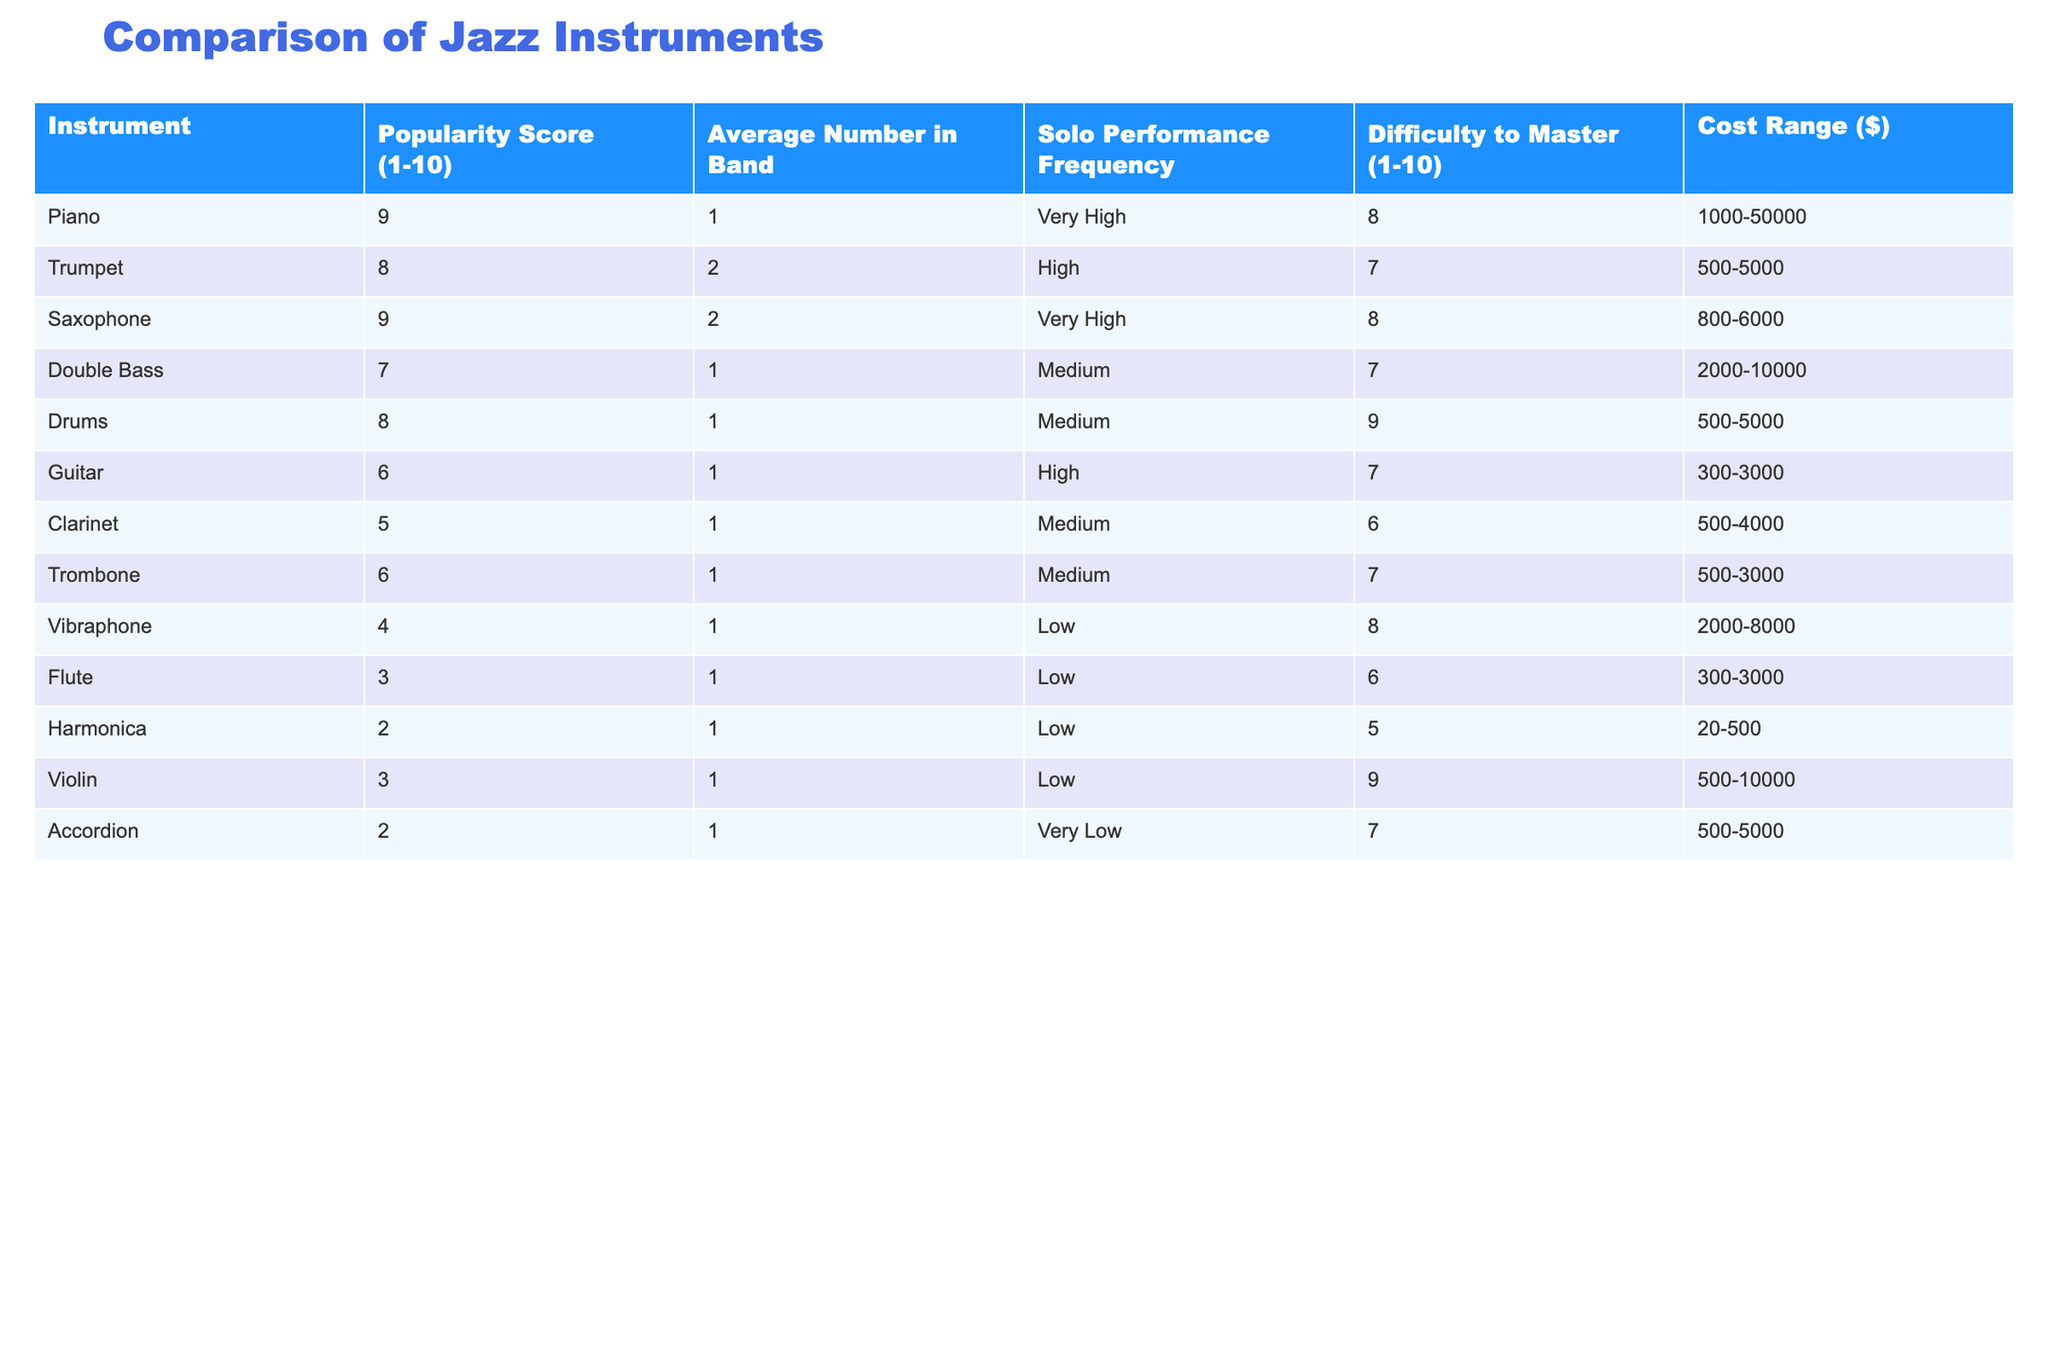What is the popularity score of the Saxophone? The Saxophone's popularity score is listed in the table under the "Popularity Score (1-10)" column, which specifically mentions the score as 9.
Answer: 9 Which instrument has the highest average number in a band? Referring to the "Average Number in Band" column, the Trumpet and Saxophone both have an average of 2, which is higher than any other instrument.
Answer: Trumpet and Saxophone What is the cost range for the Piano? The cost range for the Piano is listed in the "Cost Range ($)" column as 1000-50000.
Answer: 1000-50000 Is it true that the Clarinet is easier to master than the Harmonica? Comparing the "Difficulty to Master (1-10)" scores, the Clarinet has a score of 6 while the Harmonica has a score of 5. A lower score indicates that it is easier to master, thus making the statement true.
Answer: Yes What is the average popularity score of instruments with a solo performance frequency rated as low? The instruments with a low solo performance frequency are Flute, Harmonica, and Accordion. Their respective popularity scores are 3, 2, and 2. To find the average, sum these scores: 3 + 2 + 2 = 7, then divide by 3, yielding an average of 7/3 = approximately 2.33.
Answer: Approximately 2.33 Which instrument requires the highest level of difficulty to master, and what is that score? Reviewing the "Difficulty to Master (1-10)" column, the Drums have the highest score of 9, indicating it is the hardest to master.
Answer: Drums, 9 What is the most popular instrument based on the table? The instruments with the highest popularity scores are Piano and Saxophone, both receiving a score of 9. Thus, either can be considered the most popular.
Answer: Piano and Saxophone How many instruments have a popularity score greater than 7? Looking at the "Popularity Score (1-10)" column, the instruments with scores greater than 7 are Piano, Trumpet, Saxophone, and Drums. In total, there are 4 such instruments.
Answer: 4 What is the average cost of instruments with a popularity score of 6? The instruments with a popularity score of 6 are Guitar, Trombone, and both have cost ranges of 300-3000 and 500-3000, respectively. The average cost is not straightforward since it includes ranges, but if choosing a midpoint, (3000 + (3000 + 300) / 2 + (3000 + 500) / 2) = 3000, giving an approximate cost of 3000 per instrument score.
Answer: Approximately 3000 